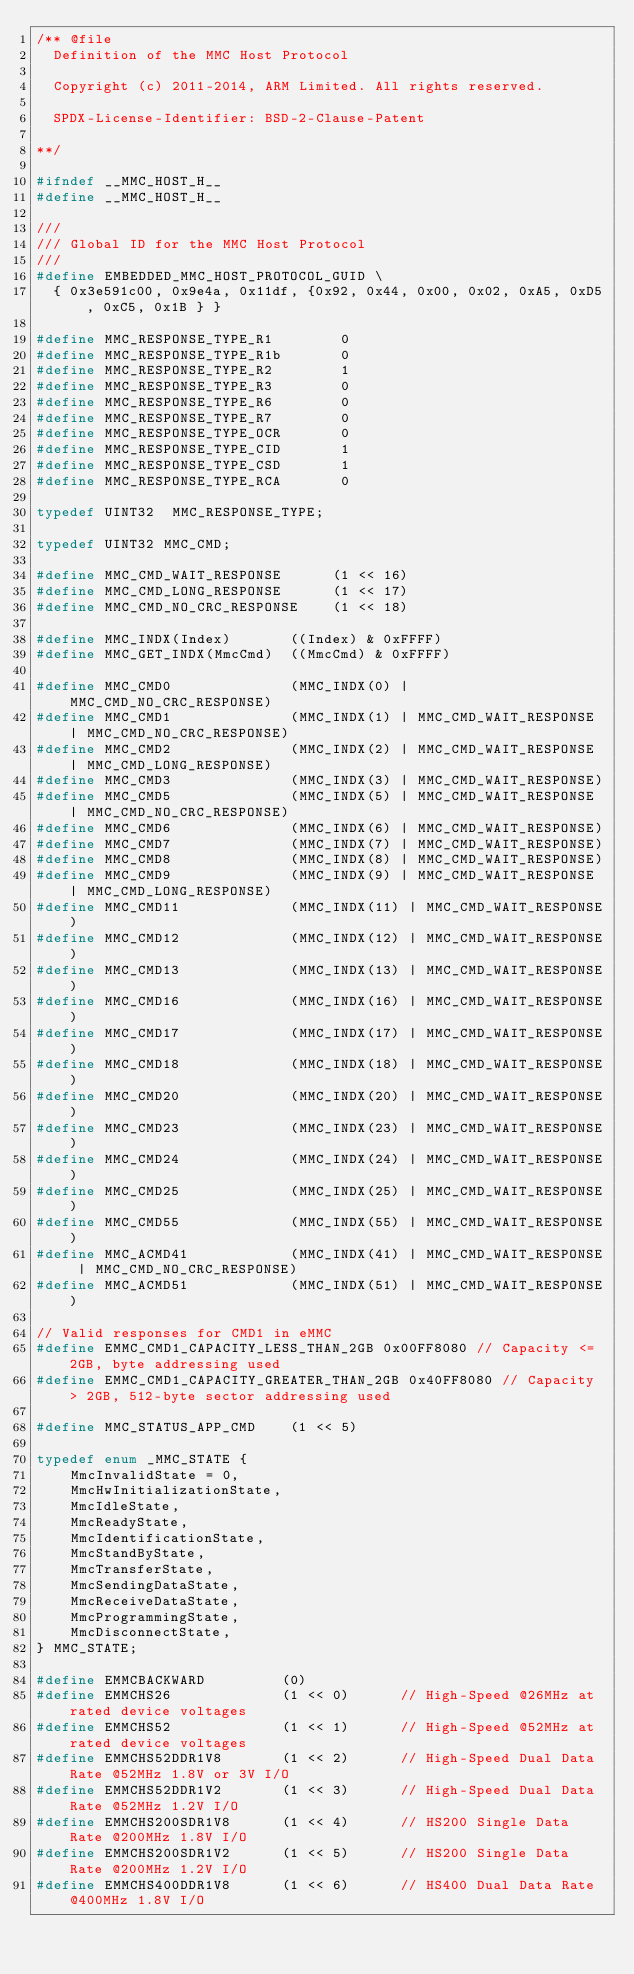<code> <loc_0><loc_0><loc_500><loc_500><_C_>/** @file
  Definition of the MMC Host Protocol

  Copyright (c) 2011-2014, ARM Limited. All rights reserved.

  SPDX-License-Identifier: BSD-2-Clause-Patent

**/

#ifndef __MMC_HOST_H__
#define __MMC_HOST_H__

///
/// Global ID for the MMC Host Protocol
///
#define EMBEDDED_MMC_HOST_PROTOCOL_GUID \
  { 0x3e591c00, 0x9e4a, 0x11df, {0x92, 0x44, 0x00, 0x02, 0xA5, 0xD5, 0xC5, 0x1B } }

#define MMC_RESPONSE_TYPE_R1        0
#define MMC_RESPONSE_TYPE_R1b       0
#define MMC_RESPONSE_TYPE_R2        1
#define MMC_RESPONSE_TYPE_R3        0
#define MMC_RESPONSE_TYPE_R6        0
#define MMC_RESPONSE_TYPE_R7        0
#define MMC_RESPONSE_TYPE_OCR       0
#define MMC_RESPONSE_TYPE_CID       1
#define MMC_RESPONSE_TYPE_CSD       1
#define MMC_RESPONSE_TYPE_RCA       0

typedef UINT32  MMC_RESPONSE_TYPE;

typedef UINT32 MMC_CMD;

#define MMC_CMD_WAIT_RESPONSE      (1 << 16)
#define MMC_CMD_LONG_RESPONSE      (1 << 17)
#define MMC_CMD_NO_CRC_RESPONSE    (1 << 18)

#define MMC_INDX(Index)       ((Index) & 0xFFFF)
#define MMC_GET_INDX(MmcCmd)  ((MmcCmd) & 0xFFFF)

#define MMC_CMD0              (MMC_INDX(0) | MMC_CMD_NO_CRC_RESPONSE)
#define MMC_CMD1              (MMC_INDX(1) | MMC_CMD_WAIT_RESPONSE | MMC_CMD_NO_CRC_RESPONSE)
#define MMC_CMD2              (MMC_INDX(2) | MMC_CMD_WAIT_RESPONSE | MMC_CMD_LONG_RESPONSE)
#define MMC_CMD3              (MMC_INDX(3) | MMC_CMD_WAIT_RESPONSE)
#define MMC_CMD5              (MMC_INDX(5) | MMC_CMD_WAIT_RESPONSE | MMC_CMD_NO_CRC_RESPONSE)
#define MMC_CMD6              (MMC_INDX(6) | MMC_CMD_WAIT_RESPONSE)
#define MMC_CMD7              (MMC_INDX(7) | MMC_CMD_WAIT_RESPONSE)
#define MMC_CMD8              (MMC_INDX(8) | MMC_CMD_WAIT_RESPONSE)
#define MMC_CMD9              (MMC_INDX(9) | MMC_CMD_WAIT_RESPONSE | MMC_CMD_LONG_RESPONSE)
#define MMC_CMD11             (MMC_INDX(11) | MMC_CMD_WAIT_RESPONSE)
#define MMC_CMD12             (MMC_INDX(12) | MMC_CMD_WAIT_RESPONSE)
#define MMC_CMD13             (MMC_INDX(13) | MMC_CMD_WAIT_RESPONSE)
#define MMC_CMD16             (MMC_INDX(16) | MMC_CMD_WAIT_RESPONSE)
#define MMC_CMD17             (MMC_INDX(17) | MMC_CMD_WAIT_RESPONSE)
#define MMC_CMD18             (MMC_INDX(18) | MMC_CMD_WAIT_RESPONSE)
#define MMC_CMD20             (MMC_INDX(20) | MMC_CMD_WAIT_RESPONSE)
#define MMC_CMD23             (MMC_INDX(23) | MMC_CMD_WAIT_RESPONSE)
#define MMC_CMD24             (MMC_INDX(24) | MMC_CMD_WAIT_RESPONSE)
#define MMC_CMD25             (MMC_INDX(25) | MMC_CMD_WAIT_RESPONSE)
#define MMC_CMD55             (MMC_INDX(55) | MMC_CMD_WAIT_RESPONSE)
#define MMC_ACMD41            (MMC_INDX(41) | MMC_CMD_WAIT_RESPONSE | MMC_CMD_NO_CRC_RESPONSE)
#define MMC_ACMD51            (MMC_INDX(51) | MMC_CMD_WAIT_RESPONSE)

// Valid responses for CMD1 in eMMC
#define EMMC_CMD1_CAPACITY_LESS_THAN_2GB 0x00FF8080 // Capacity <= 2GB, byte addressing used
#define EMMC_CMD1_CAPACITY_GREATER_THAN_2GB 0x40FF8080 // Capacity > 2GB, 512-byte sector addressing used

#define MMC_STATUS_APP_CMD    (1 << 5)

typedef enum _MMC_STATE {
    MmcInvalidState = 0,
    MmcHwInitializationState,
    MmcIdleState,
    MmcReadyState,
    MmcIdentificationState,
    MmcStandByState,
    MmcTransferState,
    MmcSendingDataState,
    MmcReceiveDataState,
    MmcProgrammingState,
    MmcDisconnectState,
} MMC_STATE;

#define EMMCBACKWARD         (0)
#define EMMCHS26             (1 << 0)      // High-Speed @26MHz at rated device voltages
#define EMMCHS52             (1 << 1)      // High-Speed @52MHz at rated device voltages
#define EMMCHS52DDR1V8       (1 << 2)      // High-Speed Dual Data Rate @52MHz 1.8V or 3V I/O
#define EMMCHS52DDR1V2       (1 << 3)      // High-Speed Dual Data Rate @52MHz 1.2V I/O
#define EMMCHS200SDR1V8      (1 << 4)      // HS200 Single Data Rate @200MHz 1.8V I/O
#define EMMCHS200SDR1V2      (1 << 5)      // HS200 Single Data Rate @200MHz 1.2V I/O
#define EMMCHS400DDR1V8      (1 << 6)      // HS400 Dual Data Rate @400MHz 1.8V I/O</code> 